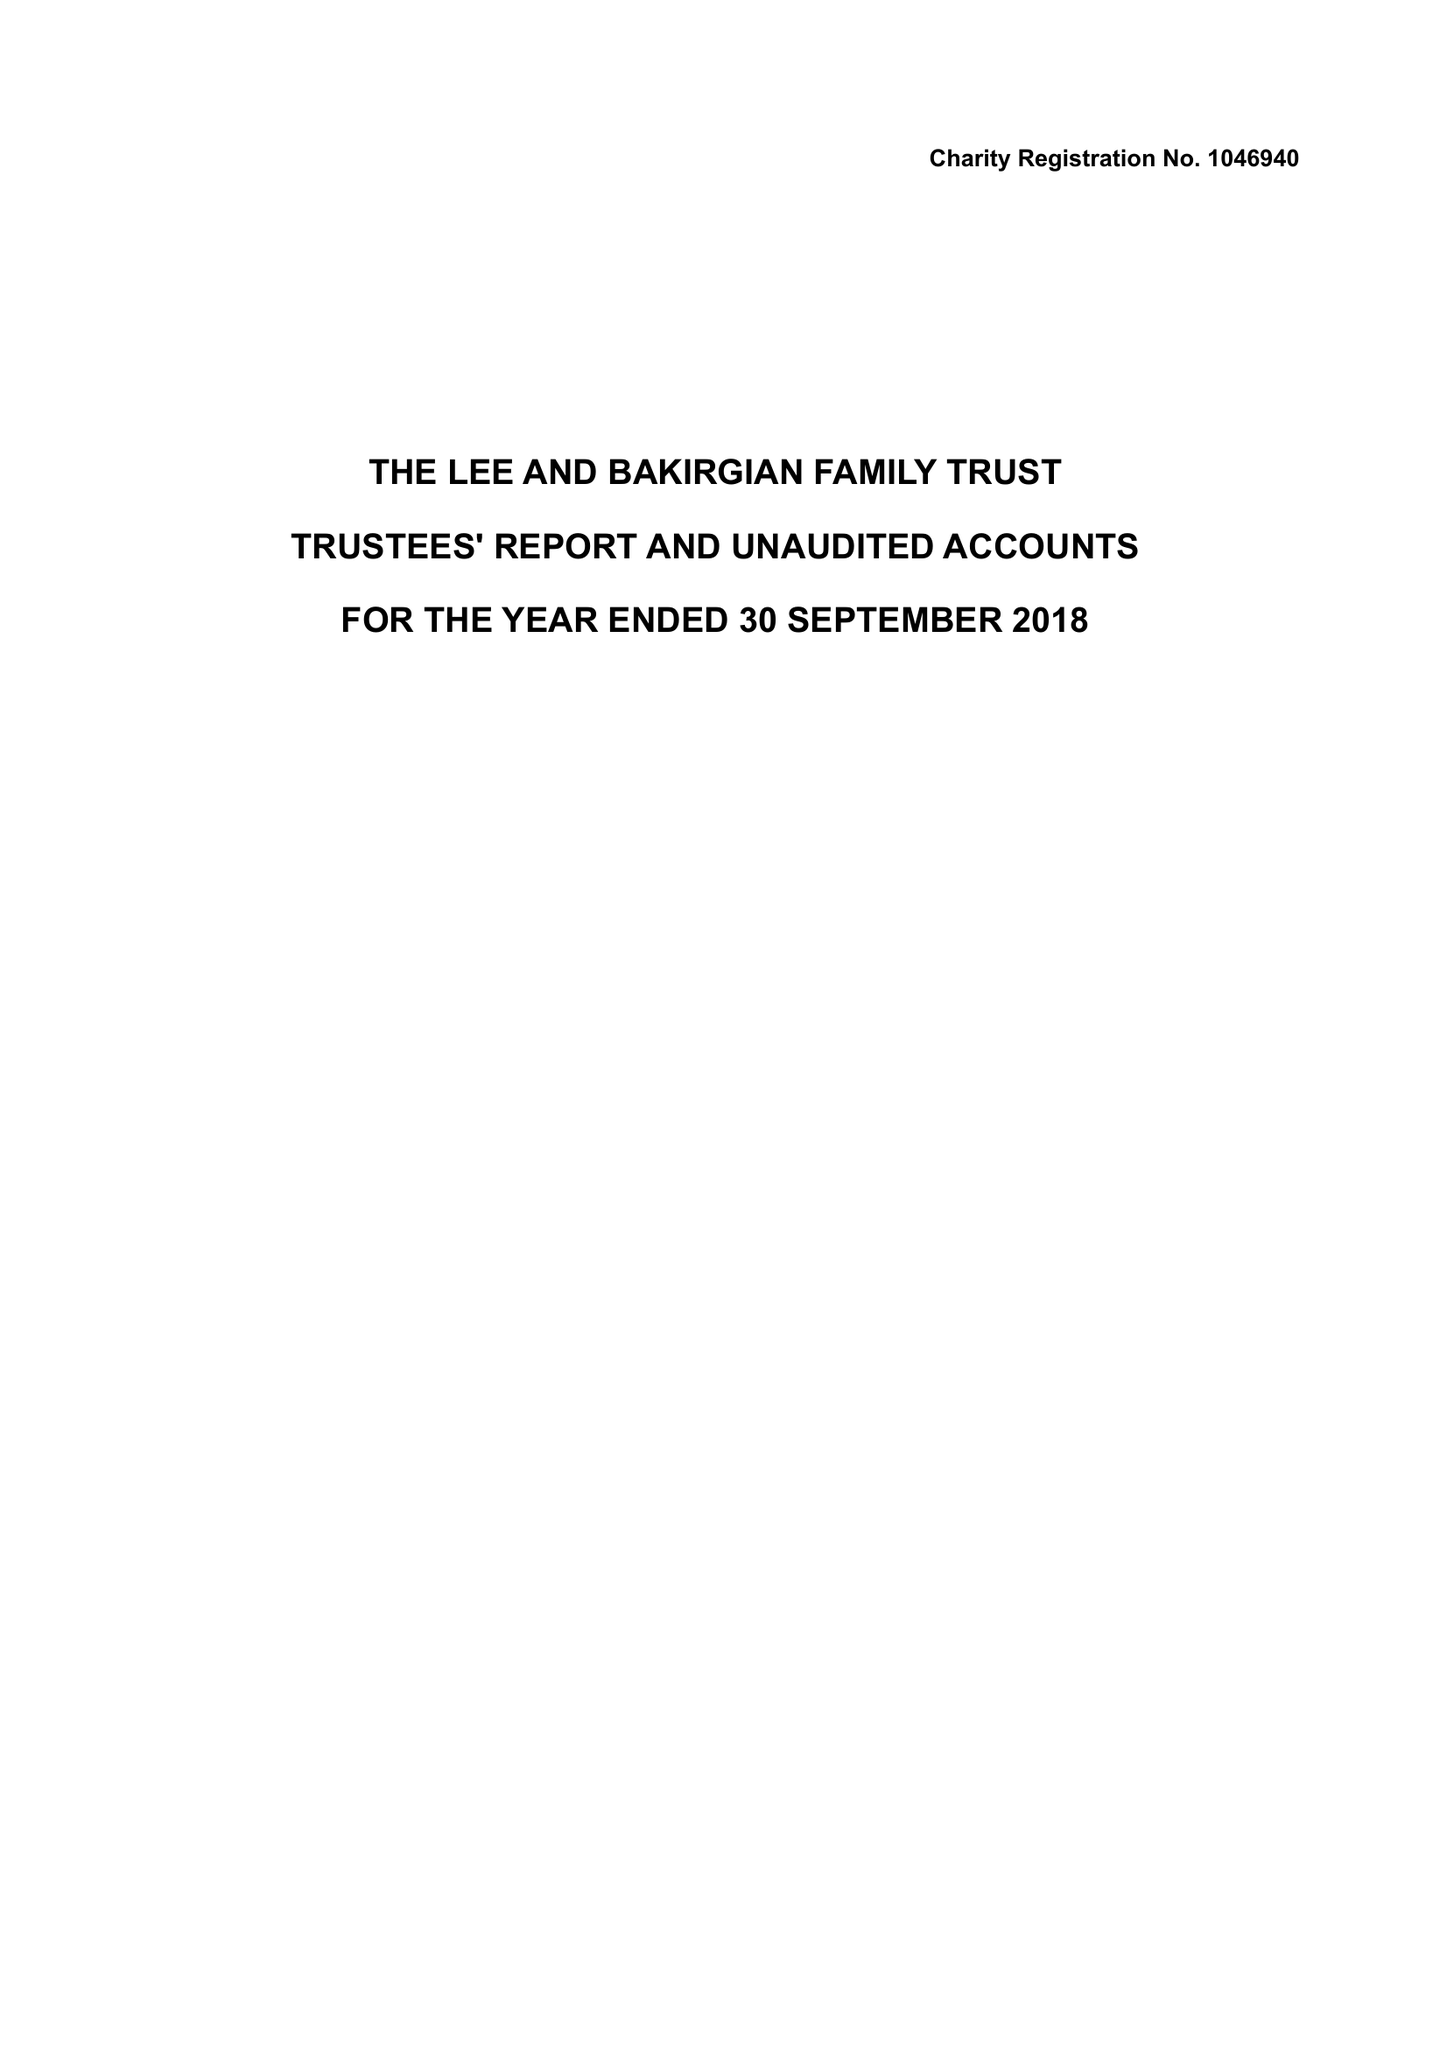What is the value for the address__postcode?
Answer the question using a single word or phrase. WA3 3JD 